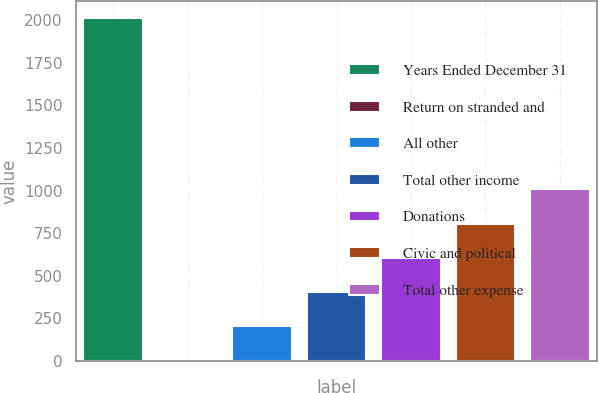Convert chart to OTSL. <chart><loc_0><loc_0><loc_500><loc_500><bar_chart><fcel>Years Ended December 31<fcel>Return on stranded and<fcel>All other<fcel>Total other income<fcel>Donations<fcel>Civic and political<fcel>Total other expense<nl><fcel>2012<fcel>1<fcel>202.1<fcel>403.2<fcel>604.3<fcel>805.4<fcel>1006.5<nl></chart> 